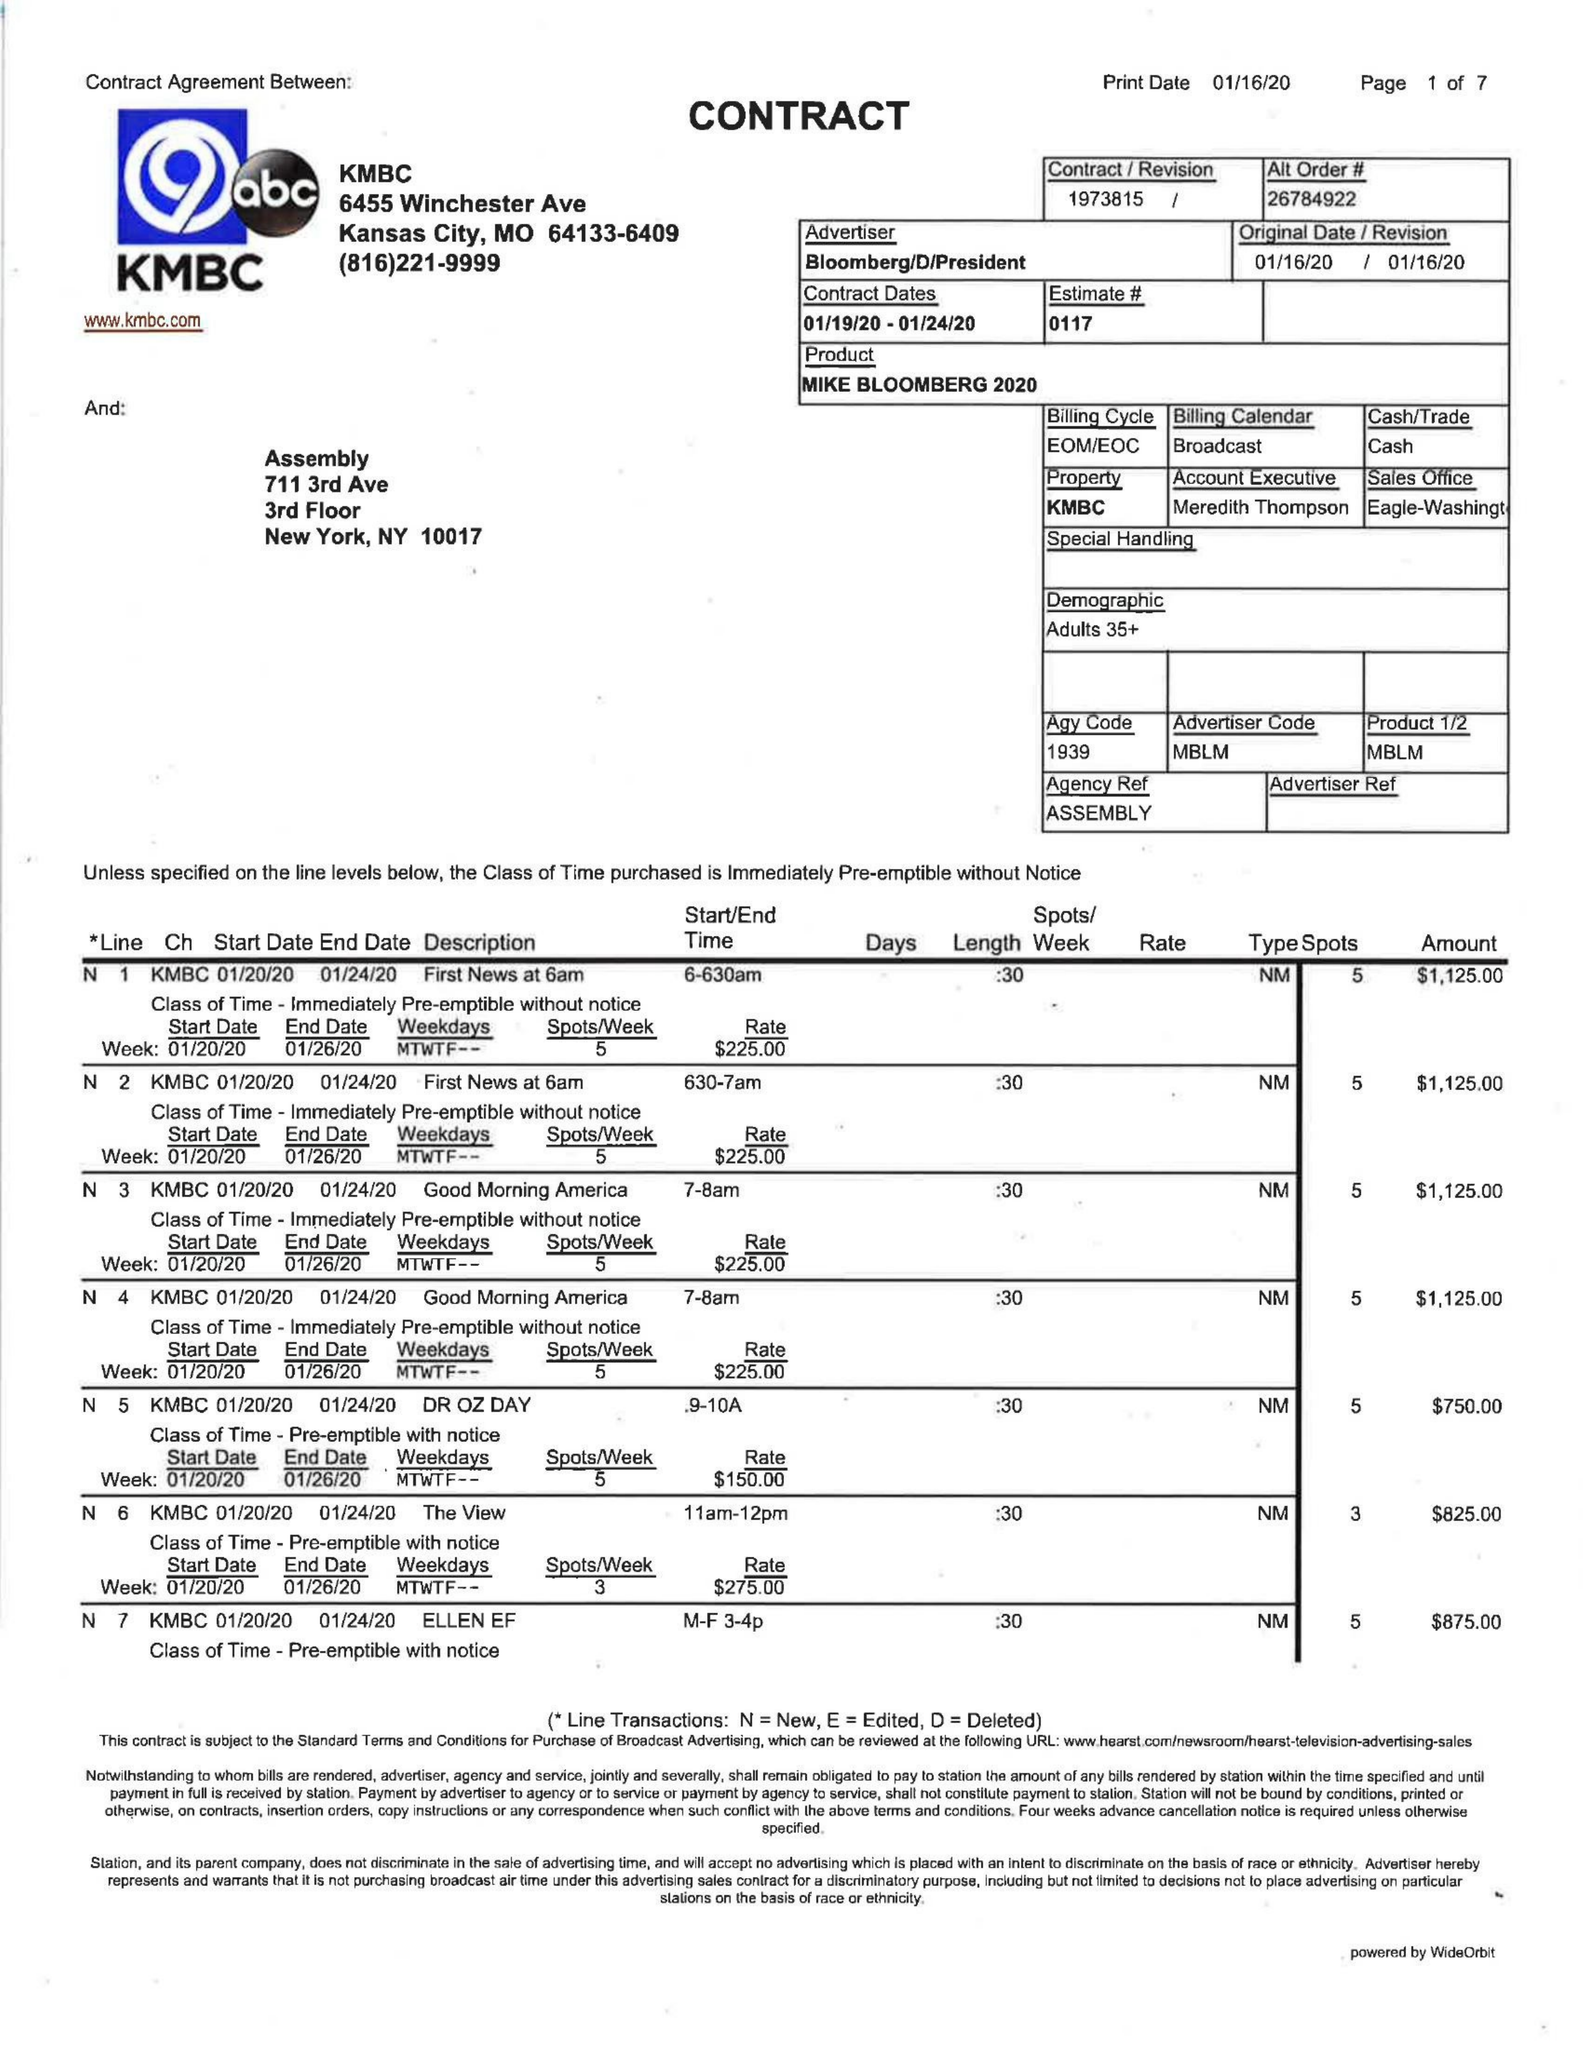What is the value for the flight_from?
Answer the question using a single word or phrase. 01/19/20 